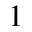Convert formula to latex. <formula><loc_0><loc_0><loc_500><loc_500>1</formula> 